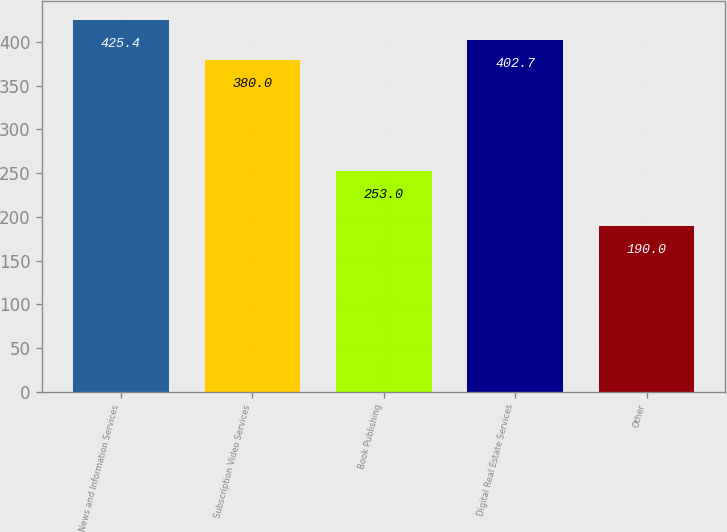<chart> <loc_0><loc_0><loc_500><loc_500><bar_chart><fcel>News and Information Services<fcel>Subscription Video Services<fcel>Book Publishing<fcel>Digital Real Estate Services<fcel>Other<nl><fcel>425.4<fcel>380<fcel>253<fcel>402.7<fcel>190<nl></chart> 